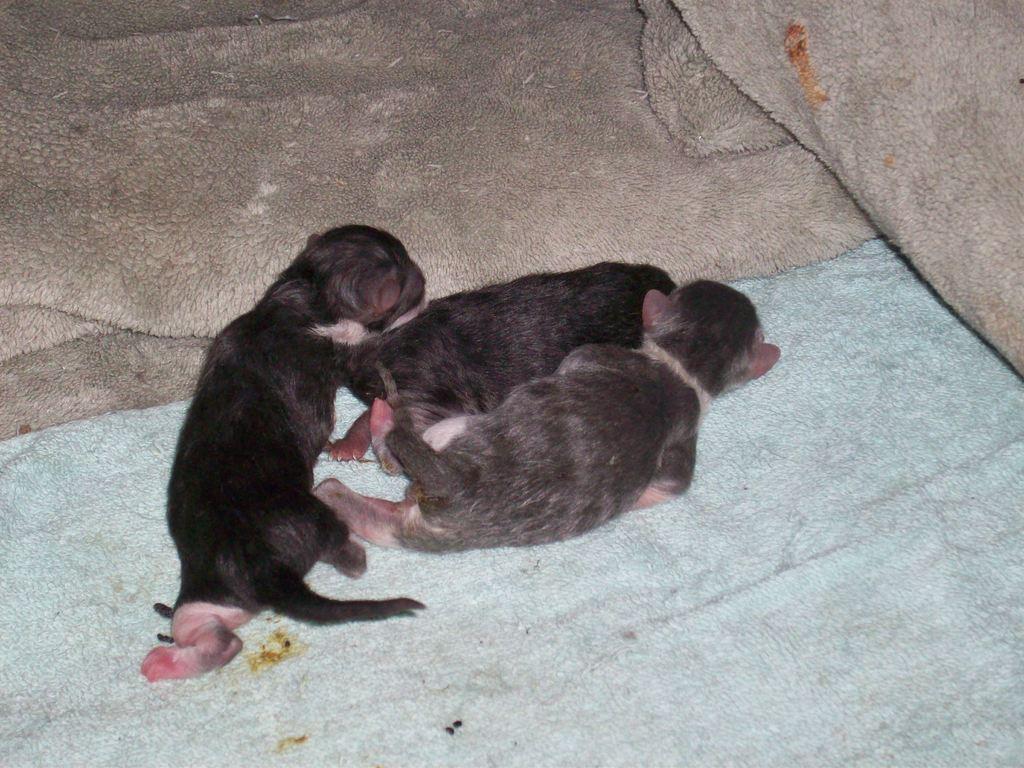Could you give a brief overview of what you see in this image? In this image I can see three black color animals are laying on a bed sheet. On the top of the image there are two more bed sheets. 